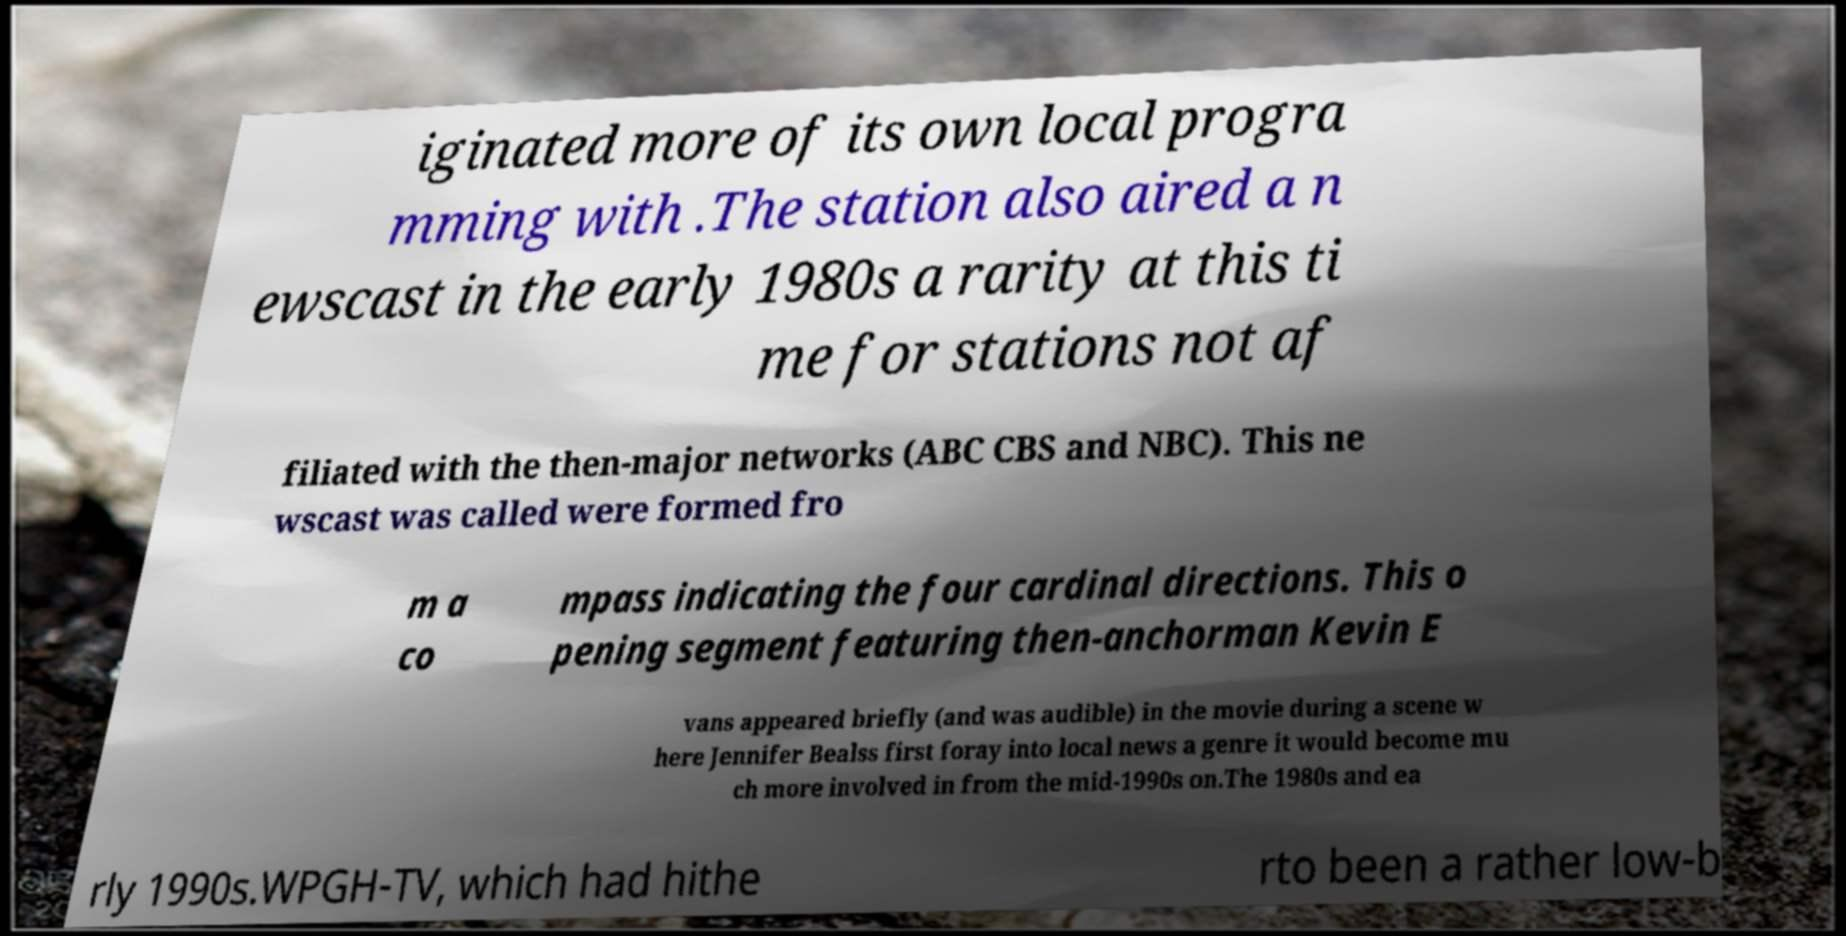I need the written content from this picture converted into text. Can you do that? iginated more of its own local progra mming with .The station also aired a n ewscast in the early 1980s a rarity at this ti me for stations not af filiated with the then-major networks (ABC CBS and NBC). This ne wscast was called were formed fro m a co mpass indicating the four cardinal directions. This o pening segment featuring then-anchorman Kevin E vans appeared briefly (and was audible) in the movie during a scene w here Jennifer Bealss first foray into local news a genre it would become mu ch more involved in from the mid-1990s on.The 1980s and ea rly 1990s.WPGH-TV, which had hithe rto been a rather low-b 